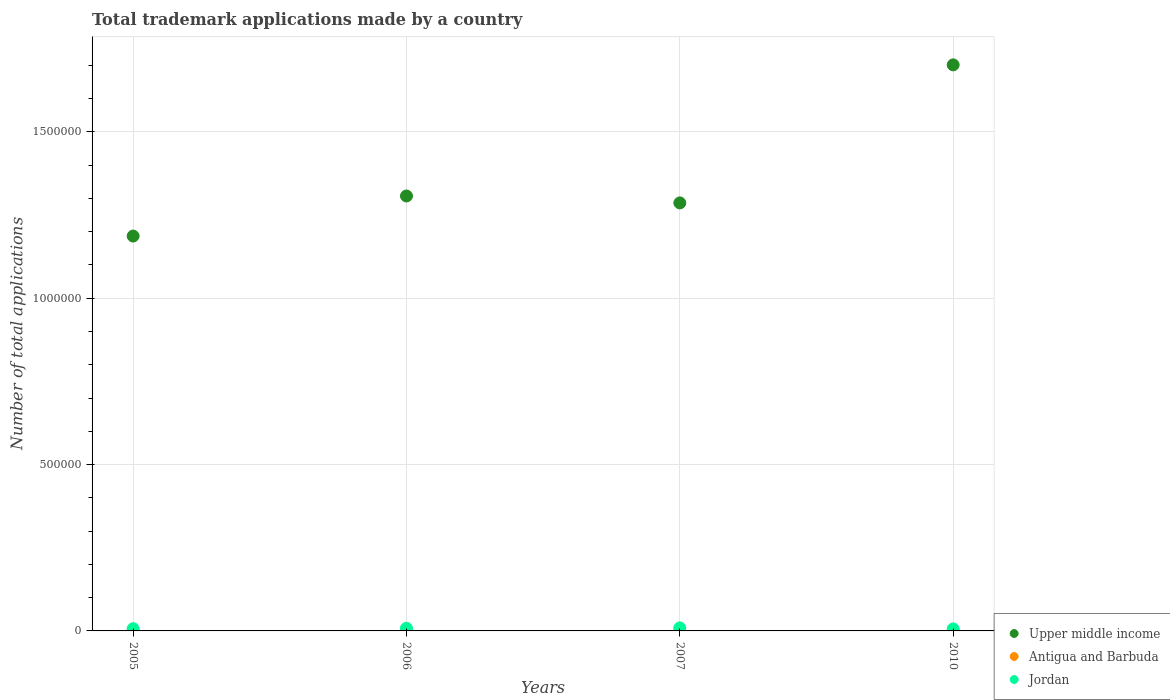What is the number of applications made by in Upper middle income in 2010?
Make the answer very short. 1.70e+06. Across all years, what is the maximum number of applications made by in Antigua and Barbuda?
Your response must be concise. 1031. Across all years, what is the minimum number of applications made by in Antigua and Barbuda?
Provide a succinct answer. 685. In which year was the number of applications made by in Antigua and Barbuda maximum?
Give a very brief answer. 2007. What is the total number of applications made by in Antigua and Barbuda in the graph?
Offer a terse response. 3719. What is the difference between the number of applications made by in Upper middle income in 2005 and that in 2010?
Offer a very short reply. -5.14e+05. What is the difference between the number of applications made by in Upper middle income in 2005 and the number of applications made by in Jordan in 2007?
Keep it short and to the point. 1.18e+06. What is the average number of applications made by in Jordan per year?
Offer a terse response. 7461.25. In the year 2006, what is the difference between the number of applications made by in Upper middle income and number of applications made by in Antigua and Barbuda?
Ensure brevity in your answer.  1.31e+06. In how many years, is the number of applications made by in Jordan greater than 1200000?
Offer a very short reply. 0. What is the ratio of the number of applications made by in Jordan in 2005 to that in 2010?
Ensure brevity in your answer.  1.12. Is the difference between the number of applications made by in Upper middle income in 2005 and 2006 greater than the difference between the number of applications made by in Antigua and Barbuda in 2005 and 2006?
Provide a succinct answer. No. What is the difference between the highest and the lowest number of applications made by in Antigua and Barbuda?
Provide a short and direct response. 346. In how many years, is the number of applications made by in Antigua and Barbuda greater than the average number of applications made by in Antigua and Barbuda taken over all years?
Offer a very short reply. 3. Is the number of applications made by in Upper middle income strictly greater than the number of applications made by in Jordan over the years?
Offer a terse response. Yes. Is the number of applications made by in Jordan strictly less than the number of applications made by in Upper middle income over the years?
Your answer should be very brief. Yes. How many dotlines are there?
Provide a succinct answer. 3. How many years are there in the graph?
Make the answer very short. 4. What is the difference between two consecutive major ticks on the Y-axis?
Offer a terse response. 5.00e+05. Are the values on the major ticks of Y-axis written in scientific E-notation?
Offer a very short reply. No. Does the graph contain any zero values?
Offer a very short reply. No. What is the title of the graph?
Provide a succinct answer. Total trademark applications made by a country. What is the label or title of the X-axis?
Provide a succinct answer. Years. What is the label or title of the Y-axis?
Give a very brief answer. Number of total applications. What is the Number of total applications in Upper middle income in 2005?
Your response must be concise. 1.19e+06. What is the Number of total applications of Antigua and Barbuda in 2005?
Offer a terse response. 1009. What is the Number of total applications of Jordan in 2005?
Give a very brief answer. 6716. What is the Number of total applications in Upper middle income in 2006?
Provide a short and direct response. 1.31e+06. What is the Number of total applications of Antigua and Barbuda in 2006?
Ensure brevity in your answer.  994. What is the Number of total applications in Jordan in 2006?
Give a very brief answer. 8013. What is the Number of total applications of Upper middle income in 2007?
Your response must be concise. 1.29e+06. What is the Number of total applications of Antigua and Barbuda in 2007?
Make the answer very short. 1031. What is the Number of total applications of Jordan in 2007?
Your answer should be compact. 9145. What is the Number of total applications of Upper middle income in 2010?
Make the answer very short. 1.70e+06. What is the Number of total applications of Antigua and Barbuda in 2010?
Your answer should be compact. 685. What is the Number of total applications in Jordan in 2010?
Offer a terse response. 5971. Across all years, what is the maximum Number of total applications in Upper middle income?
Provide a succinct answer. 1.70e+06. Across all years, what is the maximum Number of total applications of Antigua and Barbuda?
Make the answer very short. 1031. Across all years, what is the maximum Number of total applications in Jordan?
Offer a terse response. 9145. Across all years, what is the minimum Number of total applications of Upper middle income?
Keep it short and to the point. 1.19e+06. Across all years, what is the minimum Number of total applications in Antigua and Barbuda?
Your response must be concise. 685. Across all years, what is the minimum Number of total applications of Jordan?
Your response must be concise. 5971. What is the total Number of total applications of Upper middle income in the graph?
Your response must be concise. 5.48e+06. What is the total Number of total applications in Antigua and Barbuda in the graph?
Provide a succinct answer. 3719. What is the total Number of total applications of Jordan in the graph?
Give a very brief answer. 2.98e+04. What is the difference between the Number of total applications in Upper middle income in 2005 and that in 2006?
Offer a terse response. -1.20e+05. What is the difference between the Number of total applications in Jordan in 2005 and that in 2006?
Offer a very short reply. -1297. What is the difference between the Number of total applications in Upper middle income in 2005 and that in 2007?
Offer a terse response. -9.96e+04. What is the difference between the Number of total applications in Antigua and Barbuda in 2005 and that in 2007?
Keep it short and to the point. -22. What is the difference between the Number of total applications in Jordan in 2005 and that in 2007?
Offer a terse response. -2429. What is the difference between the Number of total applications in Upper middle income in 2005 and that in 2010?
Keep it short and to the point. -5.14e+05. What is the difference between the Number of total applications in Antigua and Barbuda in 2005 and that in 2010?
Your answer should be compact. 324. What is the difference between the Number of total applications of Jordan in 2005 and that in 2010?
Provide a succinct answer. 745. What is the difference between the Number of total applications of Upper middle income in 2006 and that in 2007?
Your response must be concise. 2.08e+04. What is the difference between the Number of total applications of Antigua and Barbuda in 2006 and that in 2007?
Provide a succinct answer. -37. What is the difference between the Number of total applications in Jordan in 2006 and that in 2007?
Make the answer very short. -1132. What is the difference between the Number of total applications of Upper middle income in 2006 and that in 2010?
Provide a short and direct response. -3.94e+05. What is the difference between the Number of total applications of Antigua and Barbuda in 2006 and that in 2010?
Provide a succinct answer. 309. What is the difference between the Number of total applications in Jordan in 2006 and that in 2010?
Your answer should be compact. 2042. What is the difference between the Number of total applications of Upper middle income in 2007 and that in 2010?
Provide a short and direct response. -4.15e+05. What is the difference between the Number of total applications of Antigua and Barbuda in 2007 and that in 2010?
Keep it short and to the point. 346. What is the difference between the Number of total applications of Jordan in 2007 and that in 2010?
Your answer should be very brief. 3174. What is the difference between the Number of total applications of Upper middle income in 2005 and the Number of total applications of Antigua and Barbuda in 2006?
Make the answer very short. 1.19e+06. What is the difference between the Number of total applications of Upper middle income in 2005 and the Number of total applications of Jordan in 2006?
Your answer should be compact. 1.18e+06. What is the difference between the Number of total applications of Antigua and Barbuda in 2005 and the Number of total applications of Jordan in 2006?
Make the answer very short. -7004. What is the difference between the Number of total applications of Upper middle income in 2005 and the Number of total applications of Antigua and Barbuda in 2007?
Make the answer very short. 1.19e+06. What is the difference between the Number of total applications of Upper middle income in 2005 and the Number of total applications of Jordan in 2007?
Provide a succinct answer. 1.18e+06. What is the difference between the Number of total applications of Antigua and Barbuda in 2005 and the Number of total applications of Jordan in 2007?
Your response must be concise. -8136. What is the difference between the Number of total applications of Upper middle income in 2005 and the Number of total applications of Antigua and Barbuda in 2010?
Give a very brief answer. 1.19e+06. What is the difference between the Number of total applications of Upper middle income in 2005 and the Number of total applications of Jordan in 2010?
Keep it short and to the point. 1.18e+06. What is the difference between the Number of total applications in Antigua and Barbuda in 2005 and the Number of total applications in Jordan in 2010?
Your response must be concise. -4962. What is the difference between the Number of total applications in Upper middle income in 2006 and the Number of total applications in Antigua and Barbuda in 2007?
Provide a succinct answer. 1.31e+06. What is the difference between the Number of total applications in Upper middle income in 2006 and the Number of total applications in Jordan in 2007?
Offer a terse response. 1.30e+06. What is the difference between the Number of total applications in Antigua and Barbuda in 2006 and the Number of total applications in Jordan in 2007?
Your answer should be compact. -8151. What is the difference between the Number of total applications of Upper middle income in 2006 and the Number of total applications of Antigua and Barbuda in 2010?
Give a very brief answer. 1.31e+06. What is the difference between the Number of total applications in Upper middle income in 2006 and the Number of total applications in Jordan in 2010?
Offer a very short reply. 1.30e+06. What is the difference between the Number of total applications of Antigua and Barbuda in 2006 and the Number of total applications of Jordan in 2010?
Offer a terse response. -4977. What is the difference between the Number of total applications in Upper middle income in 2007 and the Number of total applications in Antigua and Barbuda in 2010?
Make the answer very short. 1.29e+06. What is the difference between the Number of total applications of Upper middle income in 2007 and the Number of total applications of Jordan in 2010?
Your answer should be compact. 1.28e+06. What is the difference between the Number of total applications of Antigua and Barbuda in 2007 and the Number of total applications of Jordan in 2010?
Your answer should be very brief. -4940. What is the average Number of total applications of Upper middle income per year?
Your answer should be compact. 1.37e+06. What is the average Number of total applications in Antigua and Barbuda per year?
Provide a short and direct response. 929.75. What is the average Number of total applications in Jordan per year?
Your response must be concise. 7461.25. In the year 2005, what is the difference between the Number of total applications in Upper middle income and Number of total applications in Antigua and Barbuda?
Your answer should be compact. 1.19e+06. In the year 2005, what is the difference between the Number of total applications of Upper middle income and Number of total applications of Jordan?
Your answer should be very brief. 1.18e+06. In the year 2005, what is the difference between the Number of total applications in Antigua and Barbuda and Number of total applications in Jordan?
Your answer should be very brief. -5707. In the year 2006, what is the difference between the Number of total applications of Upper middle income and Number of total applications of Antigua and Barbuda?
Make the answer very short. 1.31e+06. In the year 2006, what is the difference between the Number of total applications in Upper middle income and Number of total applications in Jordan?
Offer a very short reply. 1.30e+06. In the year 2006, what is the difference between the Number of total applications in Antigua and Barbuda and Number of total applications in Jordan?
Offer a very short reply. -7019. In the year 2007, what is the difference between the Number of total applications in Upper middle income and Number of total applications in Antigua and Barbuda?
Keep it short and to the point. 1.29e+06. In the year 2007, what is the difference between the Number of total applications of Upper middle income and Number of total applications of Jordan?
Ensure brevity in your answer.  1.28e+06. In the year 2007, what is the difference between the Number of total applications of Antigua and Barbuda and Number of total applications of Jordan?
Offer a very short reply. -8114. In the year 2010, what is the difference between the Number of total applications of Upper middle income and Number of total applications of Antigua and Barbuda?
Offer a terse response. 1.70e+06. In the year 2010, what is the difference between the Number of total applications in Upper middle income and Number of total applications in Jordan?
Offer a very short reply. 1.70e+06. In the year 2010, what is the difference between the Number of total applications in Antigua and Barbuda and Number of total applications in Jordan?
Provide a succinct answer. -5286. What is the ratio of the Number of total applications in Upper middle income in 2005 to that in 2006?
Offer a terse response. 0.91. What is the ratio of the Number of total applications in Antigua and Barbuda in 2005 to that in 2006?
Offer a terse response. 1.02. What is the ratio of the Number of total applications in Jordan in 2005 to that in 2006?
Ensure brevity in your answer.  0.84. What is the ratio of the Number of total applications in Upper middle income in 2005 to that in 2007?
Ensure brevity in your answer.  0.92. What is the ratio of the Number of total applications of Antigua and Barbuda in 2005 to that in 2007?
Your answer should be very brief. 0.98. What is the ratio of the Number of total applications in Jordan in 2005 to that in 2007?
Provide a succinct answer. 0.73. What is the ratio of the Number of total applications of Upper middle income in 2005 to that in 2010?
Your response must be concise. 0.7. What is the ratio of the Number of total applications of Antigua and Barbuda in 2005 to that in 2010?
Make the answer very short. 1.47. What is the ratio of the Number of total applications of Jordan in 2005 to that in 2010?
Offer a terse response. 1.12. What is the ratio of the Number of total applications in Upper middle income in 2006 to that in 2007?
Provide a short and direct response. 1.02. What is the ratio of the Number of total applications of Antigua and Barbuda in 2006 to that in 2007?
Offer a terse response. 0.96. What is the ratio of the Number of total applications of Jordan in 2006 to that in 2007?
Keep it short and to the point. 0.88. What is the ratio of the Number of total applications in Upper middle income in 2006 to that in 2010?
Your answer should be very brief. 0.77. What is the ratio of the Number of total applications of Antigua and Barbuda in 2006 to that in 2010?
Provide a succinct answer. 1.45. What is the ratio of the Number of total applications of Jordan in 2006 to that in 2010?
Make the answer very short. 1.34. What is the ratio of the Number of total applications in Upper middle income in 2007 to that in 2010?
Offer a very short reply. 0.76. What is the ratio of the Number of total applications in Antigua and Barbuda in 2007 to that in 2010?
Offer a terse response. 1.51. What is the ratio of the Number of total applications of Jordan in 2007 to that in 2010?
Your response must be concise. 1.53. What is the difference between the highest and the second highest Number of total applications of Upper middle income?
Offer a very short reply. 3.94e+05. What is the difference between the highest and the second highest Number of total applications of Antigua and Barbuda?
Make the answer very short. 22. What is the difference between the highest and the second highest Number of total applications in Jordan?
Make the answer very short. 1132. What is the difference between the highest and the lowest Number of total applications of Upper middle income?
Your answer should be compact. 5.14e+05. What is the difference between the highest and the lowest Number of total applications in Antigua and Barbuda?
Your answer should be very brief. 346. What is the difference between the highest and the lowest Number of total applications in Jordan?
Offer a very short reply. 3174. 